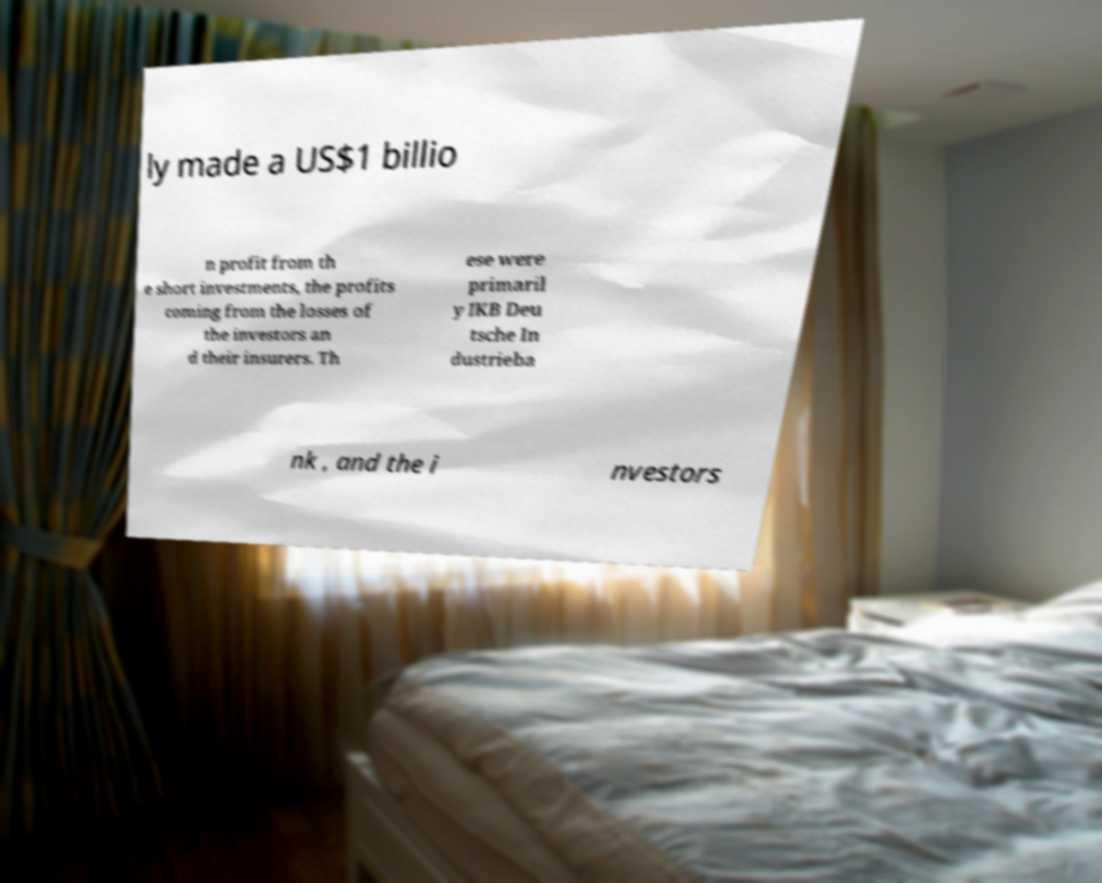Could you extract and type out the text from this image? ly made a US$1 billio n profit from th e short investments, the profits coming from the losses of the investors an d their insurers. Th ese were primaril y IKB Deu tsche In dustrieba nk , and the i nvestors 